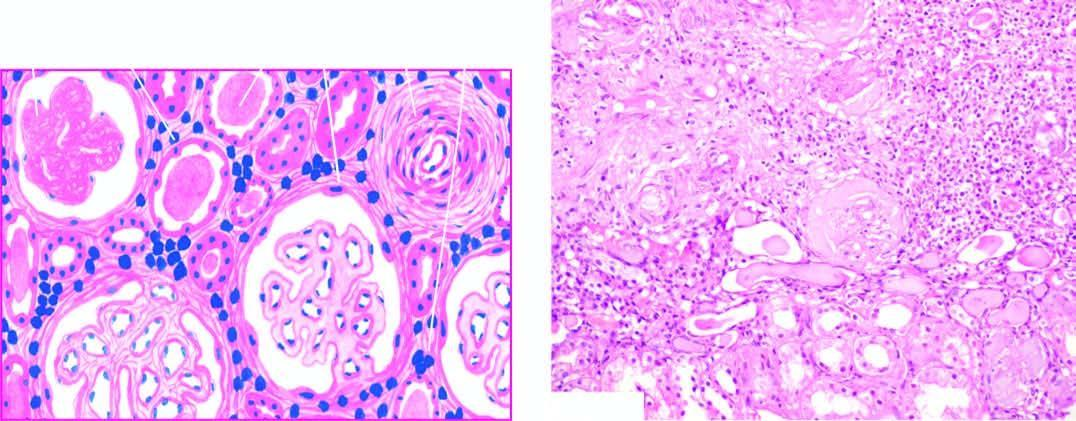what show periglomerular fibrosis?
Answer the question using a single word or phrase. Glomeruli 